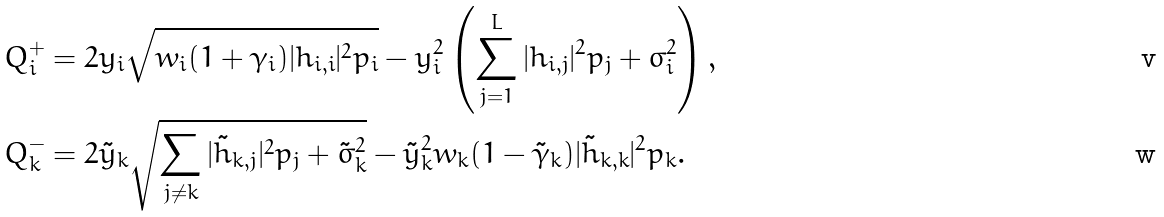<formula> <loc_0><loc_0><loc_500><loc_500>Q ^ { + } _ { i } & = 2 y _ { i } \sqrt { w _ { i } ( 1 + \gamma _ { i } ) | h _ { i , i } | ^ { 2 } p _ { i } } - y ^ { 2 } _ { i } \left ( \sum _ { j = 1 } ^ { L } | h _ { i , j } | ^ { 2 } p _ { j } + \sigma ^ { 2 } _ { i } \right ) , \\ Q _ { k } ^ { - } & = { 2 \tilde { y } _ { k } \sqrt { \sum _ { j \ne k } | \tilde { h } _ { k , j } | ^ { 2 } p _ { j } + \tilde { \sigma } ^ { 2 } _ { k } } - \tilde { y } _ { k } ^ { 2 } w _ { k } ( 1 - \tilde { \gamma } _ { k } ) | \tilde { h } _ { k , k } | ^ { 2 } p _ { k } } .</formula> 